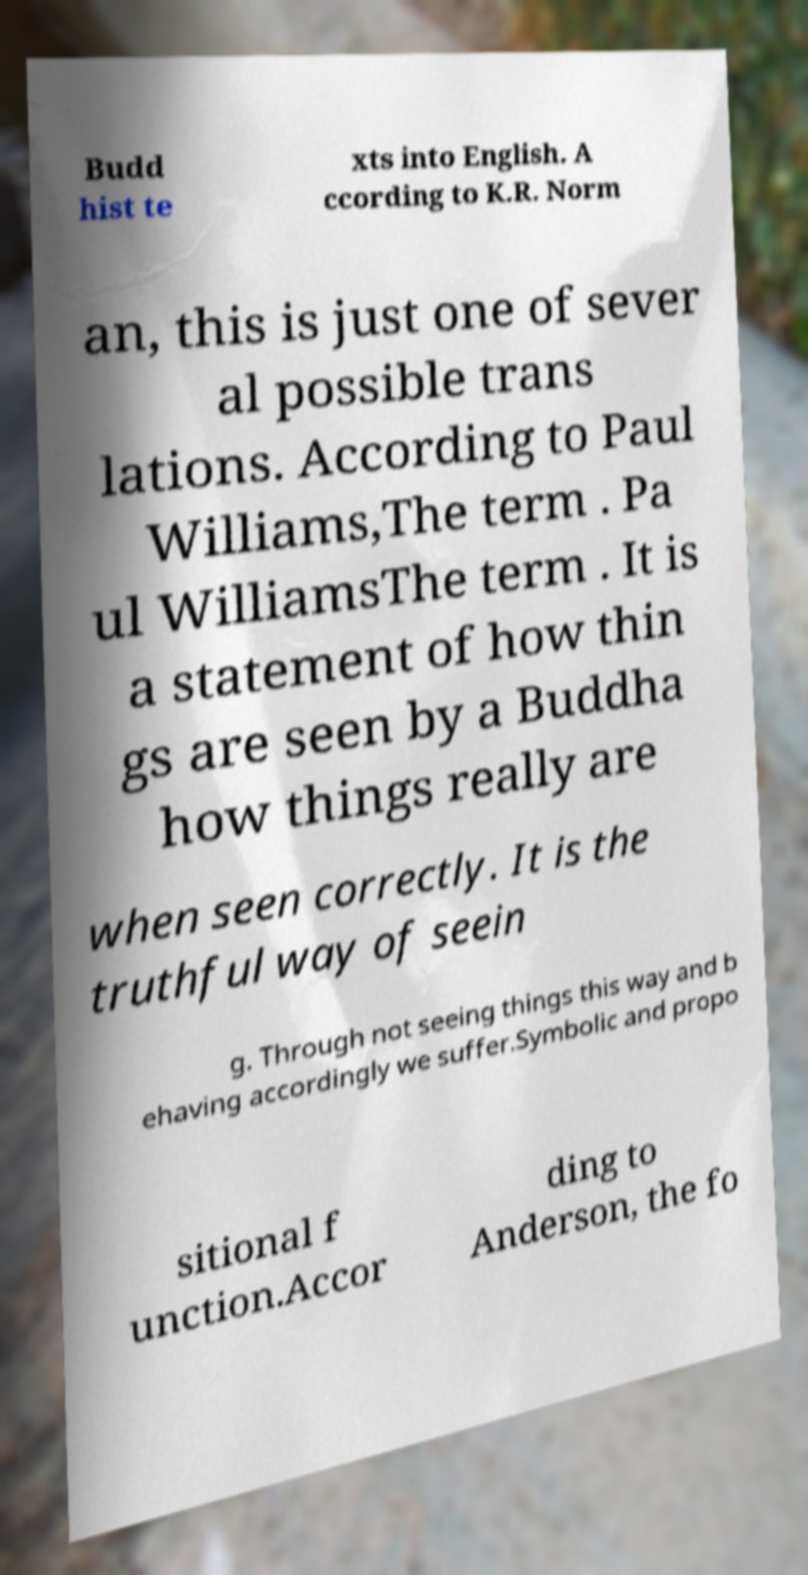Can you read and provide the text displayed in the image?This photo seems to have some interesting text. Can you extract and type it out for me? Budd hist te xts into English. A ccording to K.R. Norm an, this is just one of sever al possible trans lations. According to Paul Williams,The term . Pa ul WilliamsThe term . It is a statement of how thin gs are seen by a Buddha how things really are when seen correctly. It is the truthful way of seein g. Through not seeing things this way and b ehaving accordingly we suffer.Symbolic and propo sitional f unction.Accor ding to Anderson, the fo 